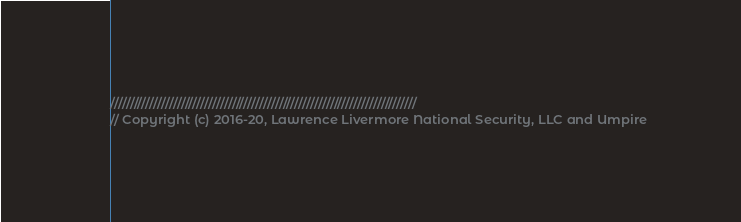Convert code to text. <code><loc_0><loc_0><loc_500><loc_500><_C++_>//////////////////////////////////////////////////////////////////////////////
// Copyright (c) 2016-20, Lawrence Livermore National Security, LLC and Umpire</code> 